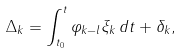Convert formula to latex. <formula><loc_0><loc_0><loc_500><loc_500>\Delta _ { k } = \int _ { t _ { 0 } } ^ { t } \varphi _ { k - l } \xi _ { k } \, d t + \delta _ { k } ,</formula> 